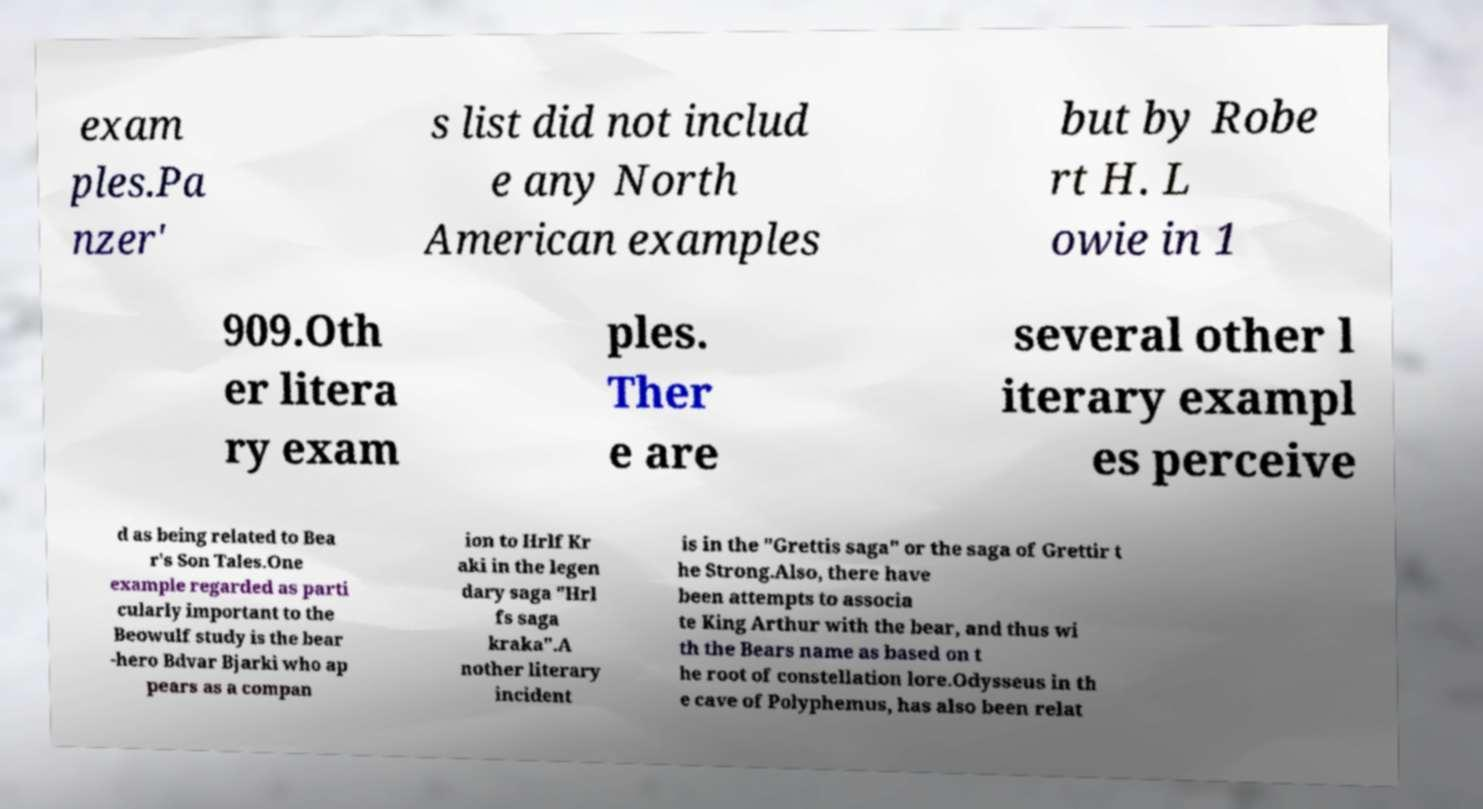Can you accurately transcribe the text from the provided image for me? exam ples.Pa nzer' s list did not includ e any North American examples but by Robe rt H. L owie in 1 909.Oth er litera ry exam ples. Ther e are several other l iterary exampl es perceive d as being related to Bea r's Son Tales.One example regarded as parti cularly important to the Beowulf study is the bear -hero Bdvar Bjarki who ap pears as a compan ion to Hrlf Kr aki in the legen dary saga "Hrl fs saga kraka".A nother literary incident is in the "Grettis saga" or the saga of Grettir t he Strong.Also, there have been attempts to associa te King Arthur with the bear, and thus wi th the Bears name as based on t he root of constellation lore.Odysseus in th e cave of Polyphemus, has also been relat 